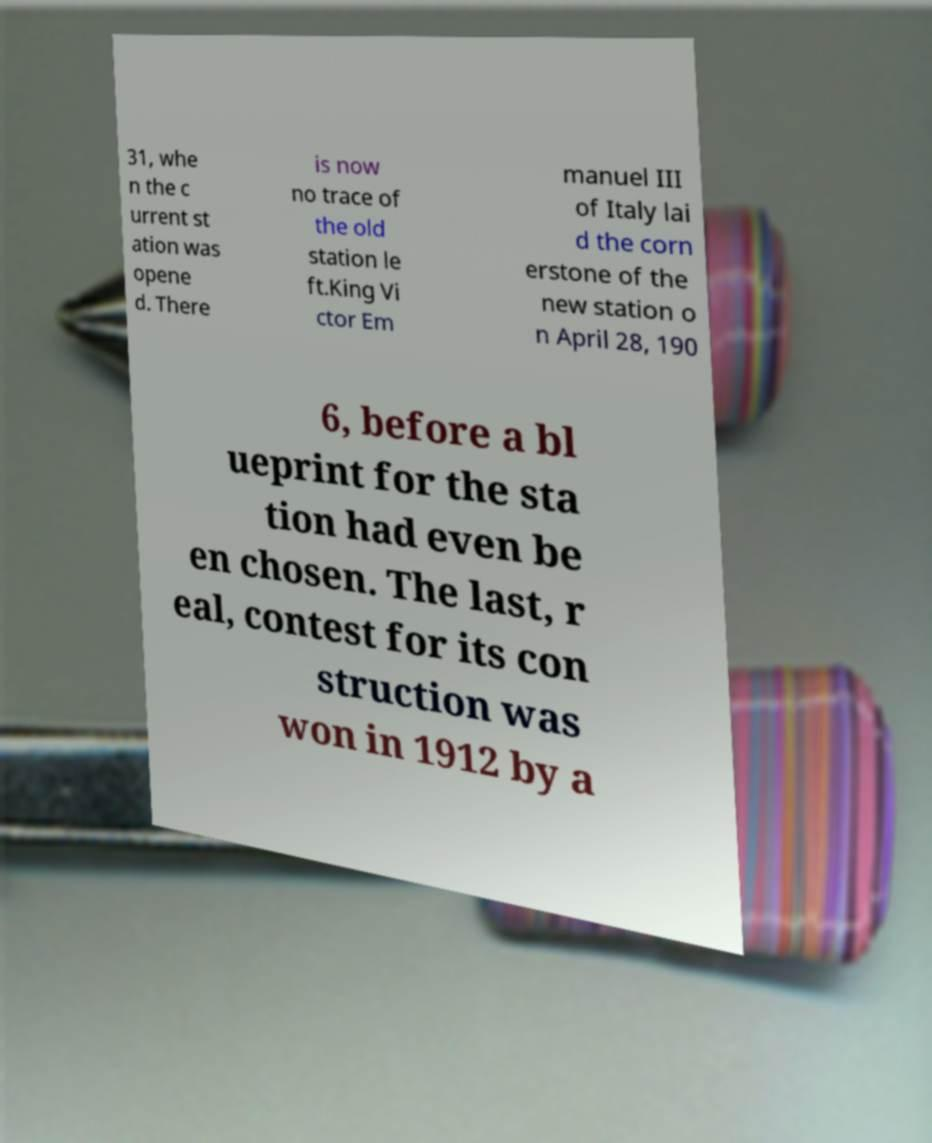Please read and relay the text visible in this image. What does it say? 31, whe n the c urrent st ation was opene d. There is now no trace of the old station le ft.King Vi ctor Em manuel III of Italy lai d the corn erstone of the new station o n April 28, 190 6, before a bl ueprint for the sta tion had even be en chosen. The last, r eal, contest for its con struction was won in 1912 by a 